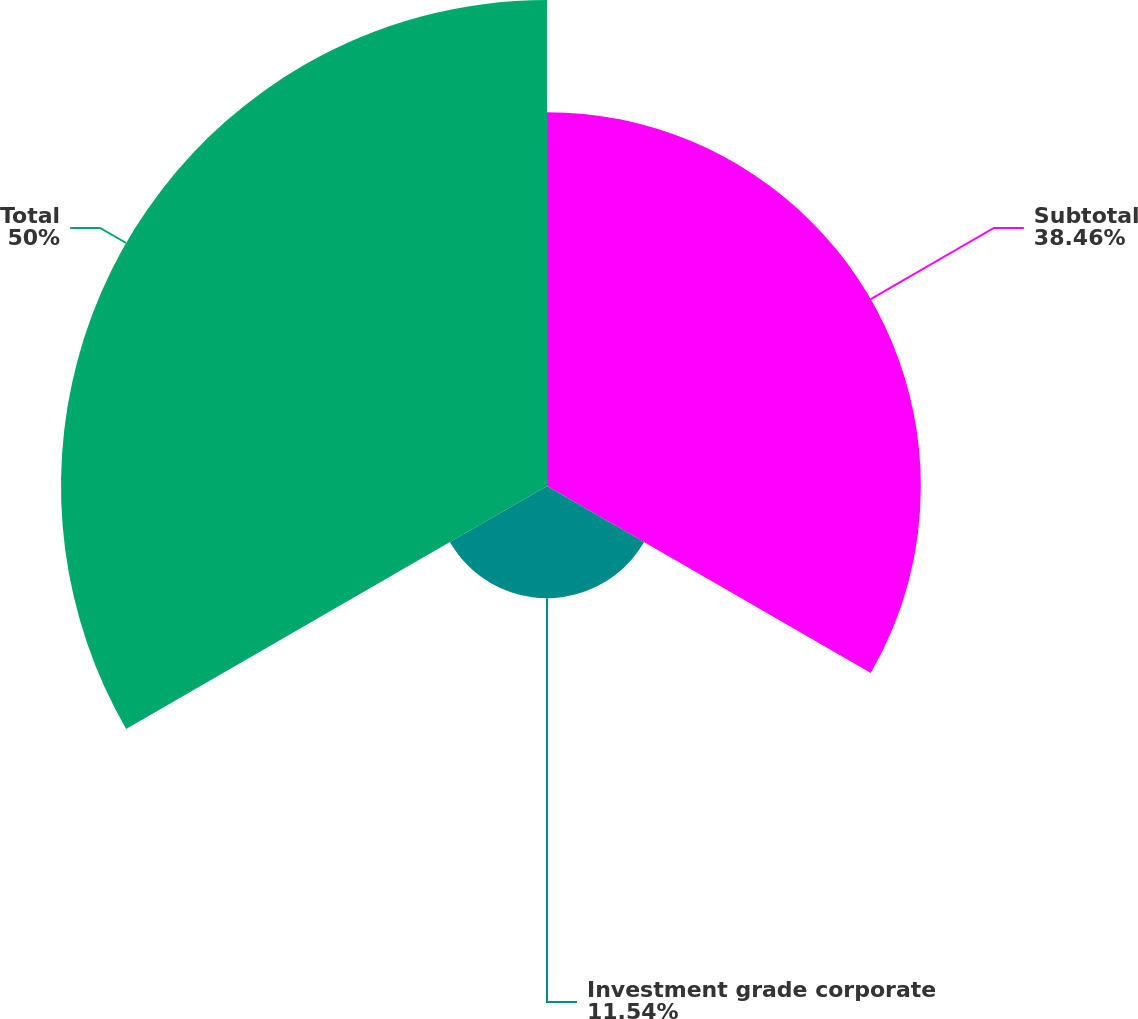Convert chart to OTSL. <chart><loc_0><loc_0><loc_500><loc_500><pie_chart><fcel>Subtotal<fcel>Investment grade corporate<fcel>Total<nl><fcel>38.46%<fcel>11.54%<fcel>50.0%<nl></chart> 